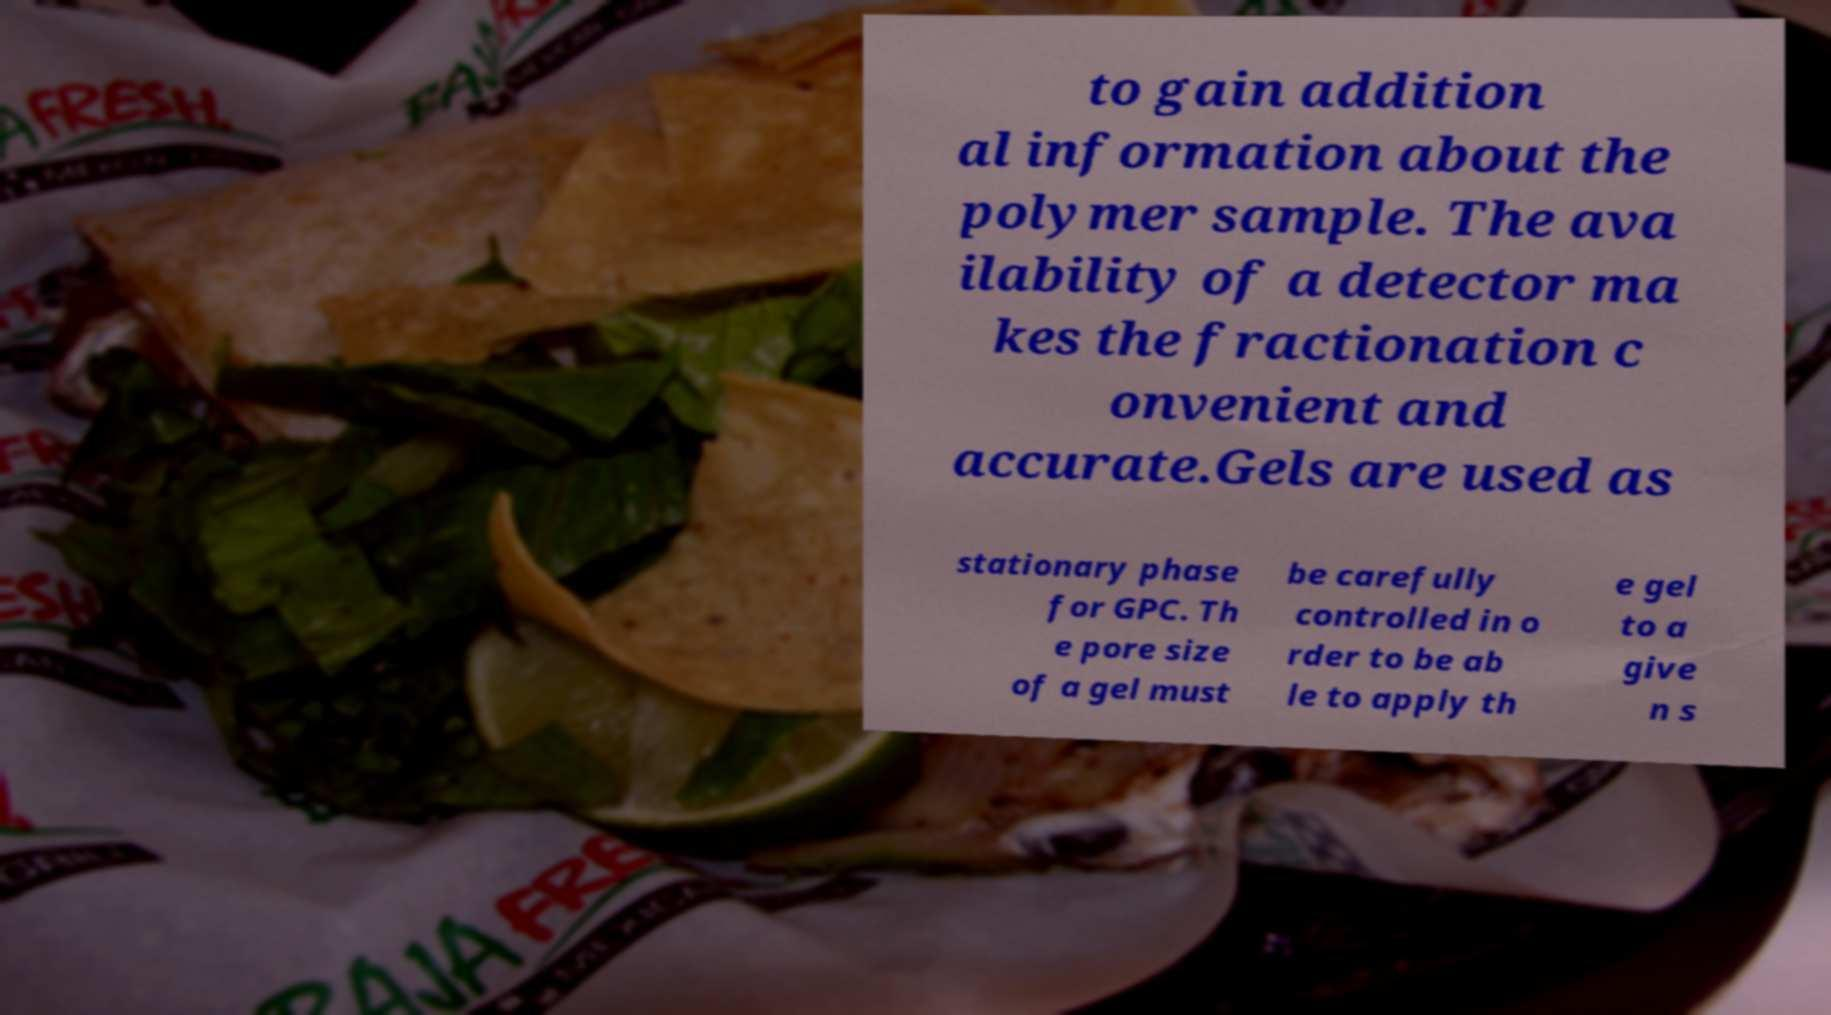Can you accurately transcribe the text from the provided image for me? to gain addition al information about the polymer sample. The ava ilability of a detector ma kes the fractionation c onvenient and accurate.Gels are used as stationary phase for GPC. Th e pore size of a gel must be carefully controlled in o rder to be ab le to apply th e gel to a give n s 